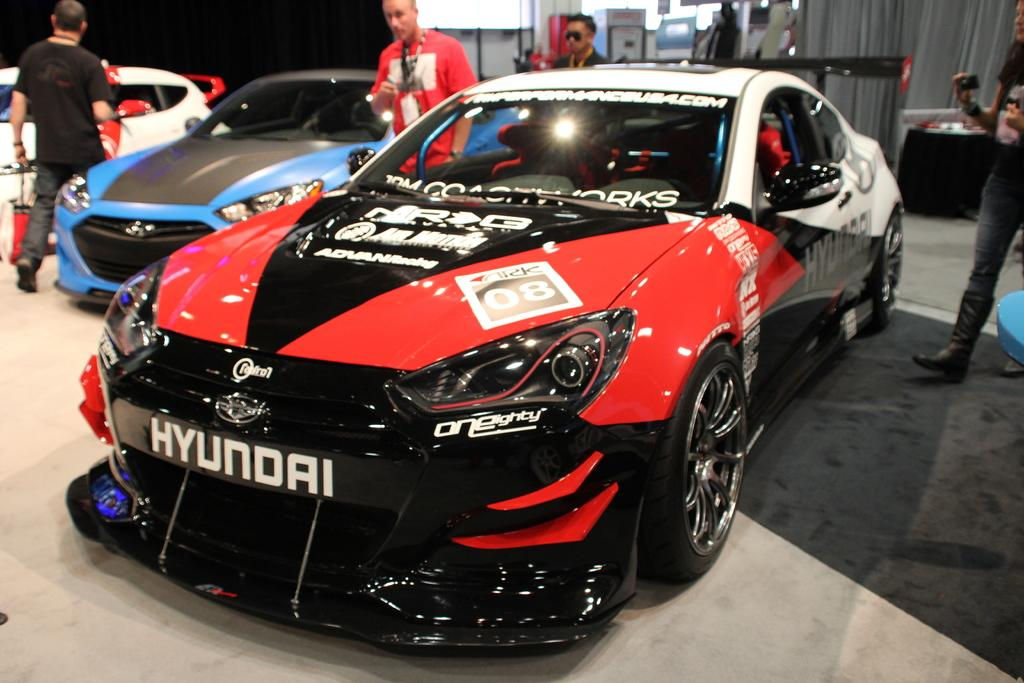What type of vehicles can be seen in the image? There are cars in the image. Can you describe the appearance of the cars? The cars are in different colors. What else is visible in the image besides the cars? There are people visible in the image. What is the purpose of the boards in the image? The purpose of the boards in the image is not specified, but they are present. How does the owl attract the attention of the crowd in the image? There is no owl present in the image, so it cannot attract the attention of any crowd. 